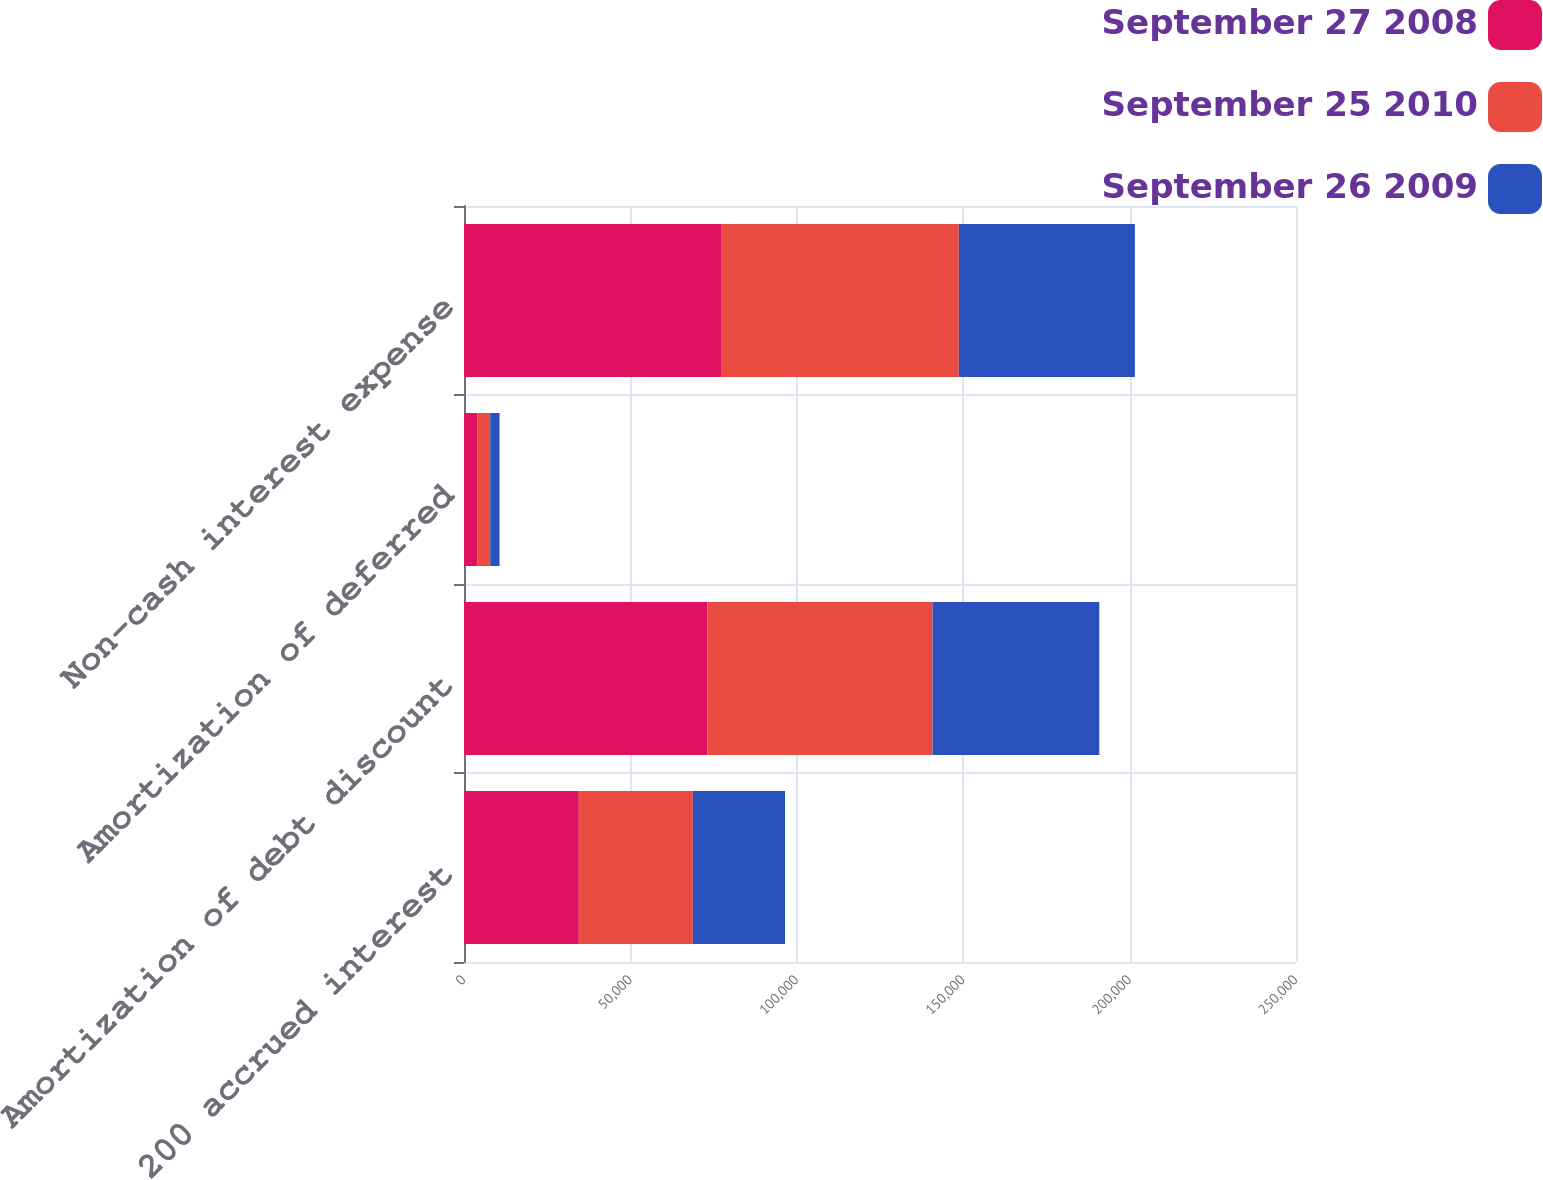<chart> <loc_0><loc_0><loc_500><loc_500><stacked_bar_chart><ecel><fcel>200 accrued interest<fcel>Amortization of debt discount<fcel>Amortization of deferred<fcel>Non-cash interest expense<nl><fcel>September 27 2008<fcel>34500<fcel>73130<fcel>4092<fcel>77222<nl><fcel>September 25 2010<fcel>34269<fcel>67673<fcel>3786<fcel>71459<nl><fcel>September 26 2009<fcel>27696<fcel>50103<fcel>2803<fcel>52906<nl></chart> 